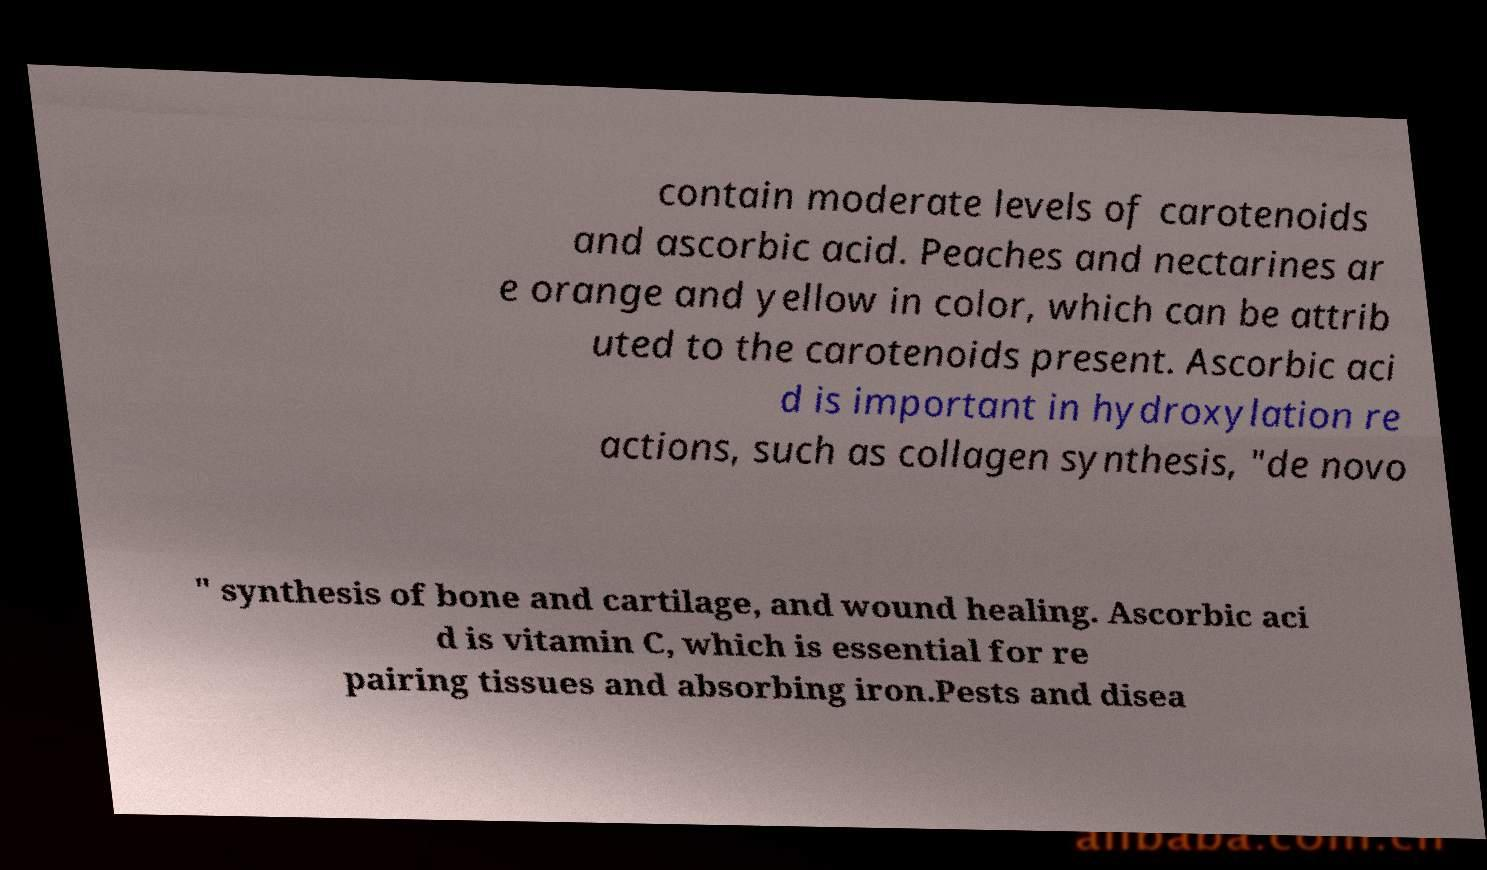For documentation purposes, I need the text within this image transcribed. Could you provide that? contain moderate levels of carotenoids and ascorbic acid. Peaches and nectarines ar e orange and yellow in color, which can be attrib uted to the carotenoids present. Ascorbic aci d is important in hydroxylation re actions, such as collagen synthesis, "de novo " synthesis of bone and cartilage, and wound healing. Ascorbic aci d is vitamin C, which is essential for re pairing tissues and absorbing iron.Pests and disea 